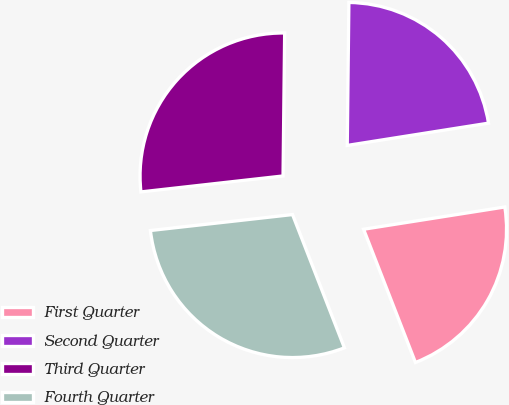<chart> <loc_0><loc_0><loc_500><loc_500><pie_chart><fcel>First Quarter<fcel>Second Quarter<fcel>Third Quarter<fcel>Fourth Quarter<nl><fcel>21.58%<fcel>22.33%<fcel>26.96%<fcel>29.13%<nl></chart> 